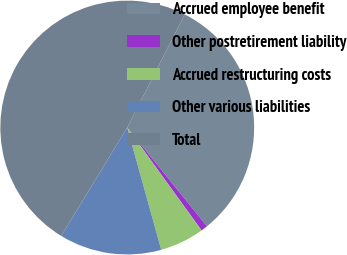Convert chart to OTSL. <chart><loc_0><loc_0><loc_500><loc_500><pie_chart><fcel>Accrued employee benefit<fcel>Other postretirement liability<fcel>Accrued restructuring costs<fcel>Other various liabilities<fcel>Total<nl><fcel>31.71%<fcel>0.85%<fcel>5.64%<fcel>13.02%<fcel>48.78%<nl></chart> 